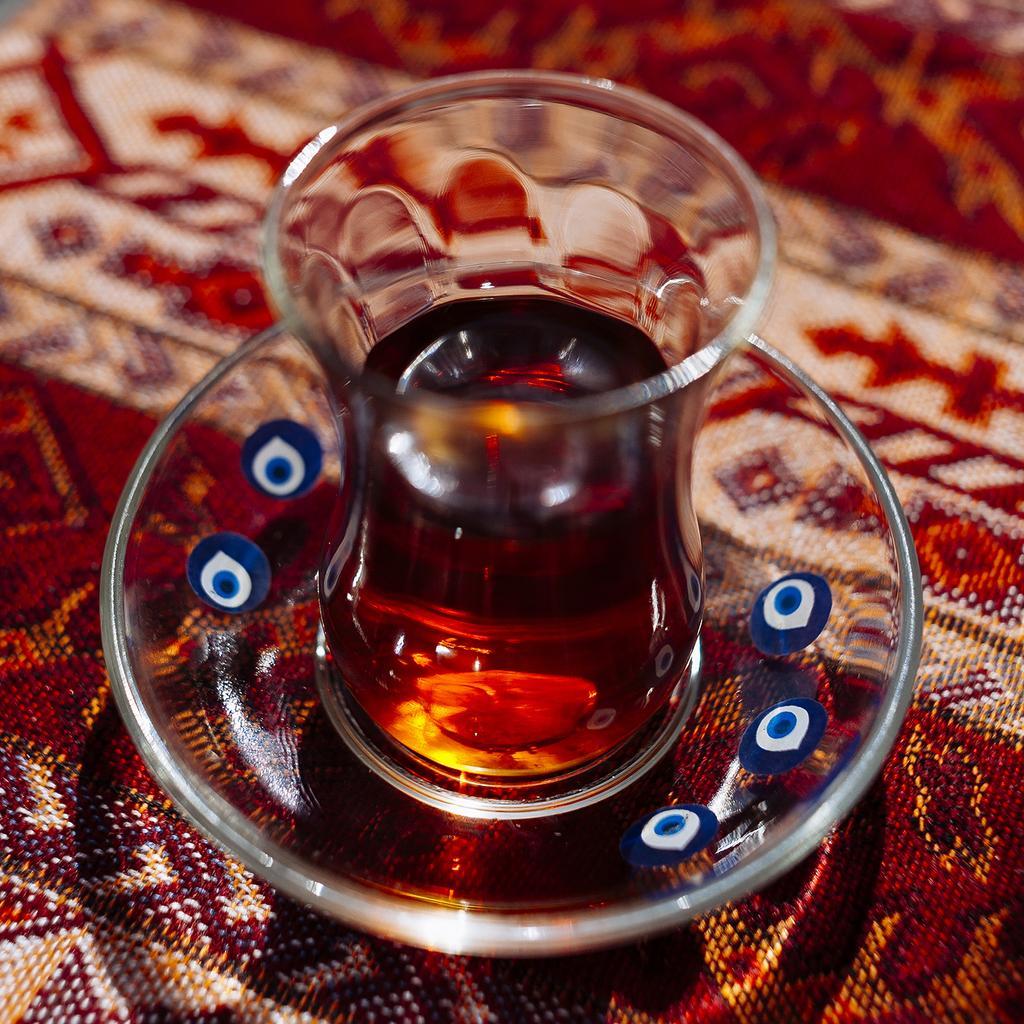In one or two sentences, can you explain what this image depicts? In this picture, we see a glass bowl and a glass containing the liquid. At the bottom, we see the carpet in white and red color. This picture is blurred in the background. 